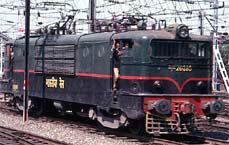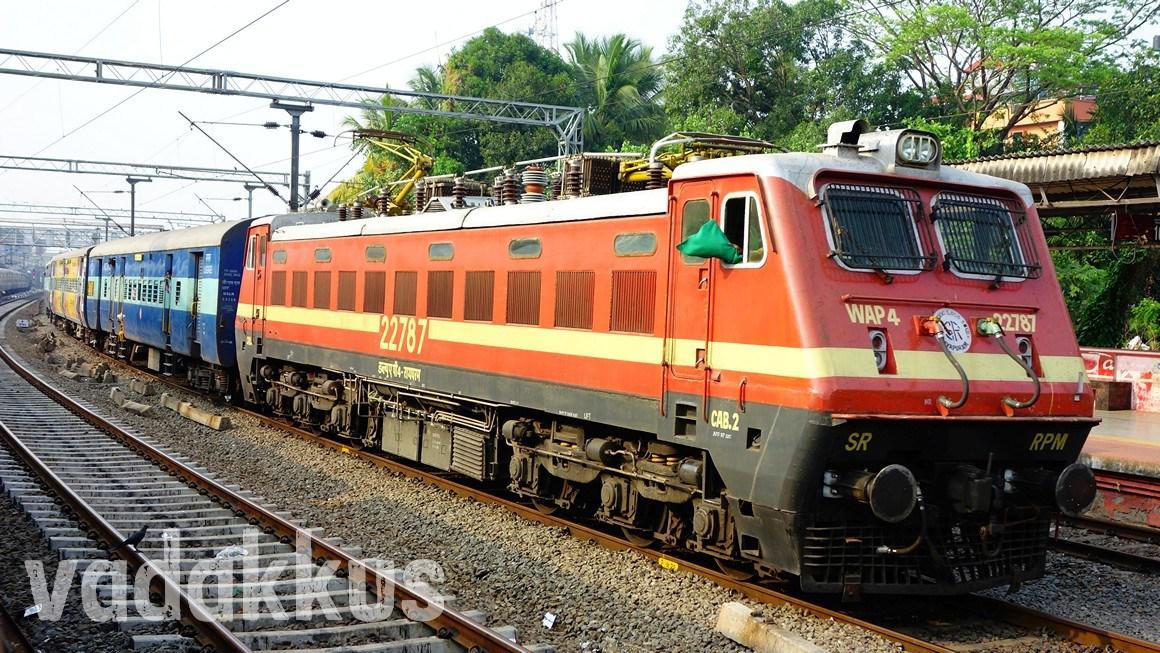The first image is the image on the left, the second image is the image on the right. Evaluate the accuracy of this statement regarding the images: "The left image includes a train that is reddish-orange with a yellow horizontal stripe.". Is it true? Answer yes or no. No. 